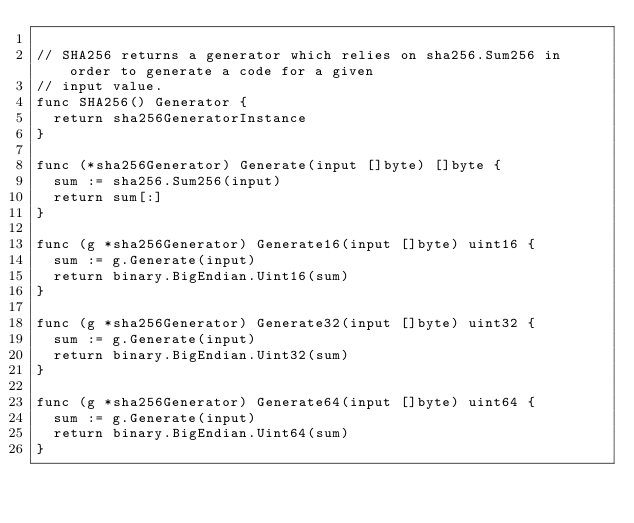Convert code to text. <code><loc_0><loc_0><loc_500><loc_500><_Go_>
// SHA256 returns a generator which relies on sha256.Sum256 in order to generate a code for a given
// input value.
func SHA256() Generator {
	return sha256GeneratorInstance
}

func (*sha256Generator) Generate(input []byte) []byte {
	sum := sha256.Sum256(input)
	return sum[:]
}

func (g *sha256Generator) Generate16(input []byte) uint16 {
	sum := g.Generate(input)
	return binary.BigEndian.Uint16(sum)
}

func (g *sha256Generator) Generate32(input []byte) uint32 {
	sum := g.Generate(input)
	return binary.BigEndian.Uint32(sum)
}

func (g *sha256Generator) Generate64(input []byte) uint64 {
	sum := g.Generate(input)
	return binary.BigEndian.Uint64(sum)
}
</code> 